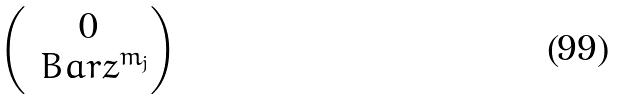Convert formula to latex. <formula><loc_0><loc_0><loc_500><loc_500>\begin{pmatrix} 0 \\ \ B a r { z } ^ { m _ { j } } \end{pmatrix}</formula> 